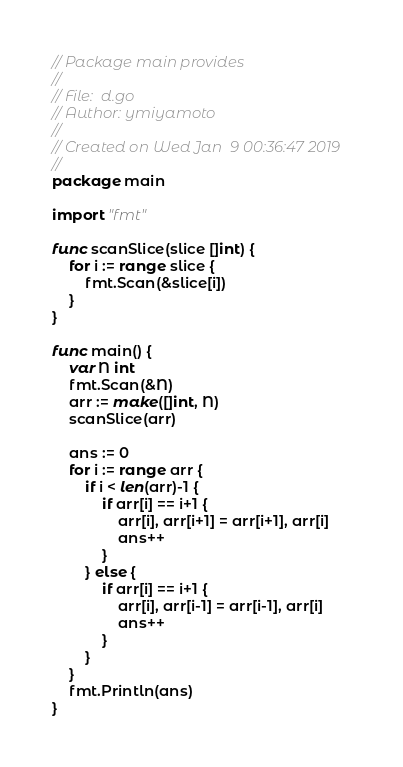<code> <loc_0><loc_0><loc_500><loc_500><_Go_>// Package main provides
//
// File:  d.go
// Author: ymiyamoto
//
// Created on Wed Jan  9 00:36:47 2019
//
package main

import "fmt"

func scanSlice(slice []int) {
	for i := range slice {
		fmt.Scan(&slice[i])
	}
}

func main() {
	var N int
	fmt.Scan(&N)
	arr := make([]int, N)
	scanSlice(arr)

	ans := 0
	for i := range arr {
		if i < len(arr)-1 {
			if arr[i] == i+1 {
				arr[i], arr[i+1] = arr[i+1], arr[i]
				ans++
			}
		} else {
			if arr[i] == i+1 {
				arr[i], arr[i-1] = arr[i-1], arr[i]
				ans++
			}
		}
	}
	fmt.Println(ans)
}
</code> 